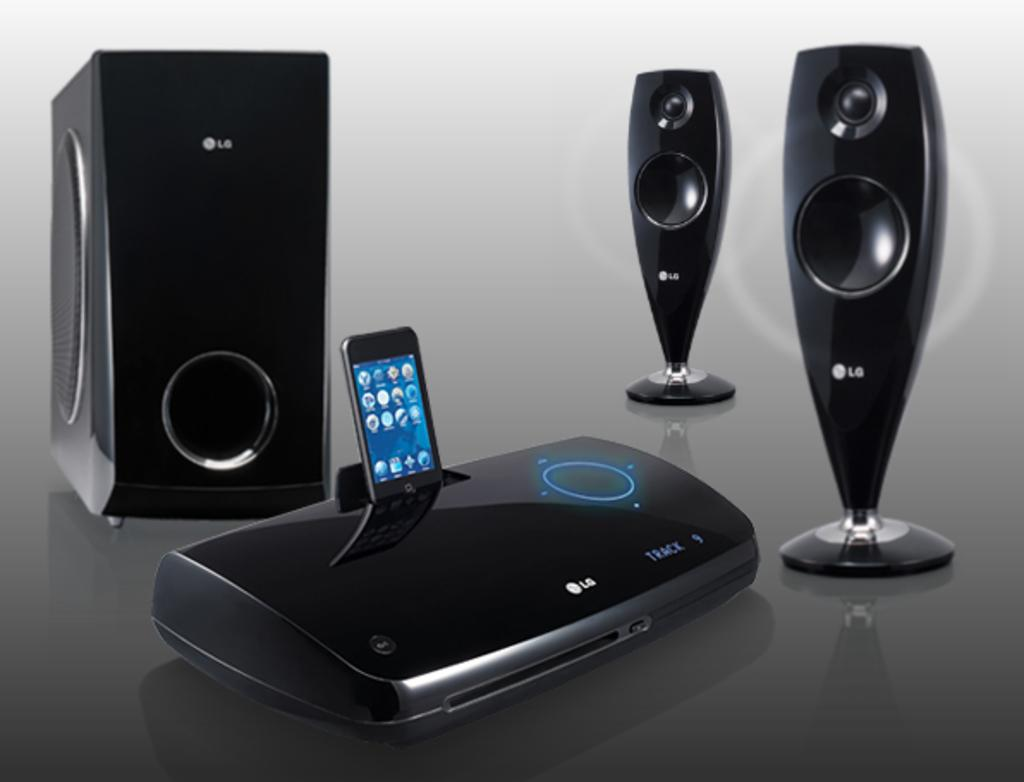<image>
Present a compact description of the photo's key features. An LG hub with speakers and a phone dock with a phone showcasing how it works 